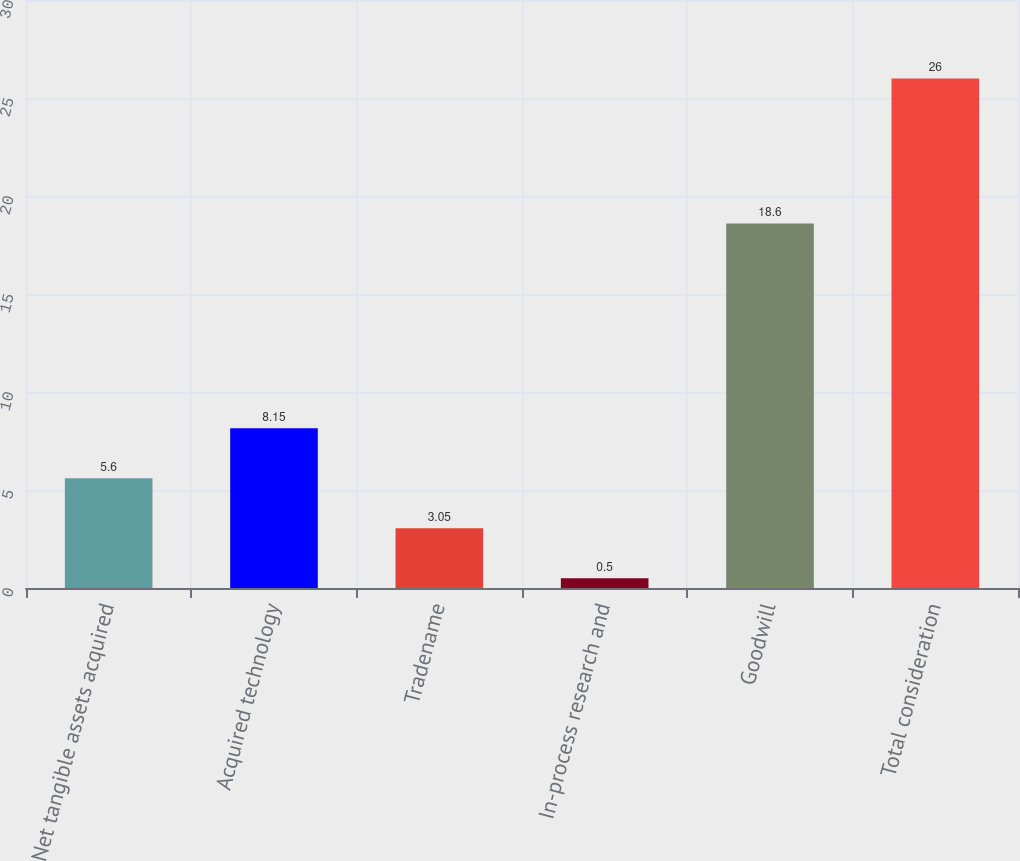Convert chart. <chart><loc_0><loc_0><loc_500><loc_500><bar_chart><fcel>Net tangible assets acquired<fcel>Acquired technology<fcel>Tradename<fcel>In-process research and<fcel>Goodwill<fcel>Total consideration<nl><fcel>5.6<fcel>8.15<fcel>3.05<fcel>0.5<fcel>18.6<fcel>26<nl></chart> 